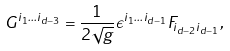<formula> <loc_0><loc_0><loc_500><loc_500>G ^ { i _ { 1 } \dots i _ { d - 3 } } = \frac { 1 } { 2 \sqrt { g } } \epsilon ^ { i _ { 1 } \dots i _ { d - 1 } } F _ { i _ { d - 2 } i _ { d - 1 } } ,</formula> 